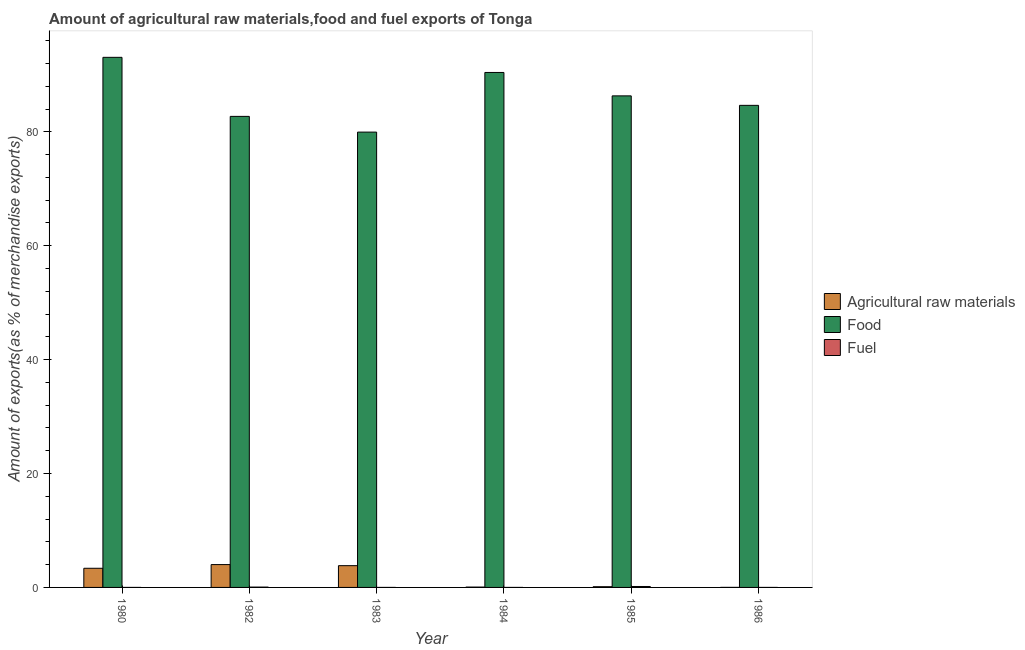How many different coloured bars are there?
Ensure brevity in your answer.  3. Are the number of bars per tick equal to the number of legend labels?
Ensure brevity in your answer.  Yes. How many bars are there on the 6th tick from the left?
Make the answer very short. 3. How many bars are there on the 4th tick from the right?
Your answer should be compact. 3. What is the label of the 5th group of bars from the left?
Offer a terse response. 1985. What is the percentage of raw materials exports in 1983?
Provide a succinct answer. 3.82. Across all years, what is the maximum percentage of food exports?
Your answer should be compact. 93.09. Across all years, what is the minimum percentage of raw materials exports?
Make the answer very short. 0.01. In which year was the percentage of raw materials exports maximum?
Offer a very short reply. 1982. What is the total percentage of raw materials exports in the graph?
Your answer should be compact. 11.39. What is the difference between the percentage of raw materials exports in 1980 and that in 1986?
Your answer should be compact. 3.36. What is the difference between the percentage of food exports in 1983 and the percentage of fuel exports in 1984?
Provide a short and direct response. -10.47. What is the average percentage of food exports per year?
Provide a short and direct response. 86.2. What is the ratio of the percentage of fuel exports in 1982 to that in 1984?
Keep it short and to the point. 92.06. What is the difference between the highest and the second highest percentage of raw materials exports?
Make the answer very short. 0.19. What is the difference between the highest and the lowest percentage of fuel exports?
Your response must be concise. 0.16. Is the sum of the percentage of food exports in 1980 and 1982 greater than the maximum percentage of fuel exports across all years?
Your answer should be very brief. Yes. What does the 1st bar from the left in 1980 represents?
Offer a very short reply. Agricultural raw materials. What does the 2nd bar from the right in 1980 represents?
Make the answer very short. Food. Is it the case that in every year, the sum of the percentage of raw materials exports and percentage of food exports is greater than the percentage of fuel exports?
Your answer should be very brief. Yes. How many bars are there?
Offer a very short reply. 18. How many years are there in the graph?
Make the answer very short. 6. Are the values on the major ticks of Y-axis written in scientific E-notation?
Keep it short and to the point. No. Does the graph contain grids?
Your response must be concise. No. What is the title of the graph?
Make the answer very short. Amount of agricultural raw materials,food and fuel exports of Tonga. What is the label or title of the Y-axis?
Ensure brevity in your answer.  Amount of exports(as % of merchandise exports). What is the Amount of exports(as % of merchandise exports) of Agricultural raw materials in 1980?
Your answer should be very brief. 3.36. What is the Amount of exports(as % of merchandise exports) in Food in 1980?
Keep it short and to the point. 93.09. What is the Amount of exports(as % of merchandise exports) of Fuel in 1980?
Offer a very short reply. 0. What is the Amount of exports(as % of merchandise exports) of Agricultural raw materials in 1982?
Keep it short and to the point. 4.01. What is the Amount of exports(as % of merchandise exports) in Food in 1982?
Ensure brevity in your answer.  82.72. What is the Amount of exports(as % of merchandise exports) in Fuel in 1982?
Give a very brief answer. 0.06. What is the Amount of exports(as % of merchandise exports) of Agricultural raw materials in 1983?
Your answer should be very brief. 3.82. What is the Amount of exports(as % of merchandise exports) in Food in 1983?
Provide a short and direct response. 79.96. What is the Amount of exports(as % of merchandise exports) of Fuel in 1983?
Offer a terse response. 0. What is the Amount of exports(as % of merchandise exports) of Agricultural raw materials in 1984?
Keep it short and to the point. 0.06. What is the Amount of exports(as % of merchandise exports) in Food in 1984?
Make the answer very short. 90.43. What is the Amount of exports(as % of merchandise exports) in Fuel in 1984?
Provide a succinct answer. 0. What is the Amount of exports(as % of merchandise exports) in Agricultural raw materials in 1985?
Your response must be concise. 0.13. What is the Amount of exports(as % of merchandise exports) in Food in 1985?
Offer a very short reply. 86.32. What is the Amount of exports(as % of merchandise exports) of Fuel in 1985?
Provide a succinct answer. 0.16. What is the Amount of exports(as % of merchandise exports) in Agricultural raw materials in 1986?
Provide a succinct answer. 0.01. What is the Amount of exports(as % of merchandise exports) in Food in 1986?
Your answer should be compact. 84.65. What is the Amount of exports(as % of merchandise exports) in Fuel in 1986?
Keep it short and to the point. 0. Across all years, what is the maximum Amount of exports(as % of merchandise exports) in Agricultural raw materials?
Provide a short and direct response. 4.01. Across all years, what is the maximum Amount of exports(as % of merchandise exports) of Food?
Provide a short and direct response. 93.09. Across all years, what is the maximum Amount of exports(as % of merchandise exports) of Fuel?
Ensure brevity in your answer.  0.16. Across all years, what is the minimum Amount of exports(as % of merchandise exports) of Agricultural raw materials?
Provide a succinct answer. 0.01. Across all years, what is the minimum Amount of exports(as % of merchandise exports) in Food?
Offer a very short reply. 79.96. Across all years, what is the minimum Amount of exports(as % of merchandise exports) in Fuel?
Your response must be concise. 0. What is the total Amount of exports(as % of merchandise exports) in Agricultural raw materials in the graph?
Offer a terse response. 11.39. What is the total Amount of exports(as % of merchandise exports) of Food in the graph?
Your response must be concise. 517.17. What is the total Amount of exports(as % of merchandise exports) of Fuel in the graph?
Ensure brevity in your answer.  0.22. What is the difference between the Amount of exports(as % of merchandise exports) in Agricultural raw materials in 1980 and that in 1982?
Your answer should be compact. -0.65. What is the difference between the Amount of exports(as % of merchandise exports) of Food in 1980 and that in 1982?
Ensure brevity in your answer.  10.37. What is the difference between the Amount of exports(as % of merchandise exports) in Fuel in 1980 and that in 1982?
Provide a succinct answer. -0.06. What is the difference between the Amount of exports(as % of merchandise exports) in Agricultural raw materials in 1980 and that in 1983?
Give a very brief answer. -0.46. What is the difference between the Amount of exports(as % of merchandise exports) of Food in 1980 and that in 1983?
Offer a terse response. 13.13. What is the difference between the Amount of exports(as % of merchandise exports) of Fuel in 1980 and that in 1983?
Your response must be concise. -0. What is the difference between the Amount of exports(as % of merchandise exports) of Agricultural raw materials in 1980 and that in 1984?
Your answer should be very brief. 3.3. What is the difference between the Amount of exports(as % of merchandise exports) in Food in 1980 and that in 1984?
Ensure brevity in your answer.  2.66. What is the difference between the Amount of exports(as % of merchandise exports) of Fuel in 1980 and that in 1984?
Offer a terse response. -0. What is the difference between the Amount of exports(as % of merchandise exports) in Agricultural raw materials in 1980 and that in 1985?
Provide a short and direct response. 3.24. What is the difference between the Amount of exports(as % of merchandise exports) in Food in 1980 and that in 1985?
Keep it short and to the point. 6.77. What is the difference between the Amount of exports(as % of merchandise exports) of Fuel in 1980 and that in 1985?
Keep it short and to the point. -0.16. What is the difference between the Amount of exports(as % of merchandise exports) of Agricultural raw materials in 1980 and that in 1986?
Your response must be concise. 3.36. What is the difference between the Amount of exports(as % of merchandise exports) in Food in 1980 and that in 1986?
Offer a terse response. 8.43. What is the difference between the Amount of exports(as % of merchandise exports) of Agricultural raw materials in 1982 and that in 1983?
Keep it short and to the point. 0.19. What is the difference between the Amount of exports(as % of merchandise exports) of Food in 1982 and that in 1983?
Offer a very short reply. 2.76. What is the difference between the Amount of exports(as % of merchandise exports) in Fuel in 1982 and that in 1983?
Your answer should be very brief. 0.06. What is the difference between the Amount of exports(as % of merchandise exports) in Agricultural raw materials in 1982 and that in 1984?
Your answer should be compact. 3.95. What is the difference between the Amount of exports(as % of merchandise exports) of Food in 1982 and that in 1984?
Your answer should be very brief. -7.71. What is the difference between the Amount of exports(as % of merchandise exports) in Fuel in 1982 and that in 1984?
Provide a short and direct response. 0.06. What is the difference between the Amount of exports(as % of merchandise exports) of Agricultural raw materials in 1982 and that in 1985?
Ensure brevity in your answer.  3.89. What is the difference between the Amount of exports(as % of merchandise exports) of Food in 1982 and that in 1985?
Offer a terse response. -3.6. What is the difference between the Amount of exports(as % of merchandise exports) in Fuel in 1982 and that in 1985?
Your response must be concise. -0.11. What is the difference between the Amount of exports(as % of merchandise exports) in Agricultural raw materials in 1982 and that in 1986?
Offer a terse response. 4. What is the difference between the Amount of exports(as % of merchandise exports) of Food in 1982 and that in 1986?
Provide a short and direct response. -1.94. What is the difference between the Amount of exports(as % of merchandise exports) in Fuel in 1982 and that in 1986?
Offer a terse response. 0.06. What is the difference between the Amount of exports(as % of merchandise exports) in Agricultural raw materials in 1983 and that in 1984?
Keep it short and to the point. 3.76. What is the difference between the Amount of exports(as % of merchandise exports) in Food in 1983 and that in 1984?
Provide a succinct answer. -10.47. What is the difference between the Amount of exports(as % of merchandise exports) in Fuel in 1983 and that in 1984?
Keep it short and to the point. -0. What is the difference between the Amount of exports(as % of merchandise exports) of Agricultural raw materials in 1983 and that in 1985?
Your answer should be very brief. 3.7. What is the difference between the Amount of exports(as % of merchandise exports) in Food in 1983 and that in 1985?
Your answer should be compact. -6.36. What is the difference between the Amount of exports(as % of merchandise exports) of Fuel in 1983 and that in 1985?
Ensure brevity in your answer.  -0.16. What is the difference between the Amount of exports(as % of merchandise exports) of Agricultural raw materials in 1983 and that in 1986?
Offer a terse response. 3.81. What is the difference between the Amount of exports(as % of merchandise exports) of Food in 1983 and that in 1986?
Give a very brief answer. -4.7. What is the difference between the Amount of exports(as % of merchandise exports) of Fuel in 1983 and that in 1986?
Your answer should be very brief. 0. What is the difference between the Amount of exports(as % of merchandise exports) in Agricultural raw materials in 1984 and that in 1985?
Offer a very short reply. -0.07. What is the difference between the Amount of exports(as % of merchandise exports) of Food in 1984 and that in 1985?
Your response must be concise. 4.11. What is the difference between the Amount of exports(as % of merchandise exports) in Fuel in 1984 and that in 1985?
Your response must be concise. -0.16. What is the difference between the Amount of exports(as % of merchandise exports) of Agricultural raw materials in 1984 and that in 1986?
Make the answer very short. 0.05. What is the difference between the Amount of exports(as % of merchandise exports) of Food in 1984 and that in 1986?
Your response must be concise. 5.78. What is the difference between the Amount of exports(as % of merchandise exports) in Agricultural raw materials in 1985 and that in 1986?
Offer a terse response. 0.12. What is the difference between the Amount of exports(as % of merchandise exports) in Food in 1985 and that in 1986?
Your answer should be very brief. 1.67. What is the difference between the Amount of exports(as % of merchandise exports) of Fuel in 1985 and that in 1986?
Make the answer very short. 0.16. What is the difference between the Amount of exports(as % of merchandise exports) of Agricultural raw materials in 1980 and the Amount of exports(as % of merchandise exports) of Food in 1982?
Your answer should be compact. -79.35. What is the difference between the Amount of exports(as % of merchandise exports) of Agricultural raw materials in 1980 and the Amount of exports(as % of merchandise exports) of Fuel in 1982?
Keep it short and to the point. 3.31. What is the difference between the Amount of exports(as % of merchandise exports) in Food in 1980 and the Amount of exports(as % of merchandise exports) in Fuel in 1982?
Offer a terse response. 93.03. What is the difference between the Amount of exports(as % of merchandise exports) of Agricultural raw materials in 1980 and the Amount of exports(as % of merchandise exports) of Food in 1983?
Ensure brevity in your answer.  -76.59. What is the difference between the Amount of exports(as % of merchandise exports) in Agricultural raw materials in 1980 and the Amount of exports(as % of merchandise exports) in Fuel in 1983?
Your answer should be very brief. 3.36. What is the difference between the Amount of exports(as % of merchandise exports) in Food in 1980 and the Amount of exports(as % of merchandise exports) in Fuel in 1983?
Keep it short and to the point. 93.09. What is the difference between the Amount of exports(as % of merchandise exports) of Agricultural raw materials in 1980 and the Amount of exports(as % of merchandise exports) of Food in 1984?
Give a very brief answer. -87.07. What is the difference between the Amount of exports(as % of merchandise exports) of Agricultural raw materials in 1980 and the Amount of exports(as % of merchandise exports) of Fuel in 1984?
Your answer should be very brief. 3.36. What is the difference between the Amount of exports(as % of merchandise exports) of Food in 1980 and the Amount of exports(as % of merchandise exports) of Fuel in 1984?
Provide a short and direct response. 93.09. What is the difference between the Amount of exports(as % of merchandise exports) of Agricultural raw materials in 1980 and the Amount of exports(as % of merchandise exports) of Food in 1985?
Make the answer very short. -82.96. What is the difference between the Amount of exports(as % of merchandise exports) in Agricultural raw materials in 1980 and the Amount of exports(as % of merchandise exports) in Fuel in 1985?
Your answer should be very brief. 3.2. What is the difference between the Amount of exports(as % of merchandise exports) of Food in 1980 and the Amount of exports(as % of merchandise exports) of Fuel in 1985?
Offer a very short reply. 92.92. What is the difference between the Amount of exports(as % of merchandise exports) of Agricultural raw materials in 1980 and the Amount of exports(as % of merchandise exports) of Food in 1986?
Provide a short and direct response. -81.29. What is the difference between the Amount of exports(as % of merchandise exports) of Agricultural raw materials in 1980 and the Amount of exports(as % of merchandise exports) of Fuel in 1986?
Your answer should be compact. 3.36. What is the difference between the Amount of exports(as % of merchandise exports) of Food in 1980 and the Amount of exports(as % of merchandise exports) of Fuel in 1986?
Keep it short and to the point. 93.09. What is the difference between the Amount of exports(as % of merchandise exports) of Agricultural raw materials in 1982 and the Amount of exports(as % of merchandise exports) of Food in 1983?
Your response must be concise. -75.95. What is the difference between the Amount of exports(as % of merchandise exports) in Agricultural raw materials in 1982 and the Amount of exports(as % of merchandise exports) in Fuel in 1983?
Give a very brief answer. 4.01. What is the difference between the Amount of exports(as % of merchandise exports) of Food in 1982 and the Amount of exports(as % of merchandise exports) of Fuel in 1983?
Offer a terse response. 82.72. What is the difference between the Amount of exports(as % of merchandise exports) in Agricultural raw materials in 1982 and the Amount of exports(as % of merchandise exports) in Food in 1984?
Keep it short and to the point. -86.42. What is the difference between the Amount of exports(as % of merchandise exports) of Agricultural raw materials in 1982 and the Amount of exports(as % of merchandise exports) of Fuel in 1984?
Your answer should be compact. 4.01. What is the difference between the Amount of exports(as % of merchandise exports) of Food in 1982 and the Amount of exports(as % of merchandise exports) of Fuel in 1984?
Keep it short and to the point. 82.72. What is the difference between the Amount of exports(as % of merchandise exports) of Agricultural raw materials in 1982 and the Amount of exports(as % of merchandise exports) of Food in 1985?
Provide a succinct answer. -82.31. What is the difference between the Amount of exports(as % of merchandise exports) of Agricultural raw materials in 1982 and the Amount of exports(as % of merchandise exports) of Fuel in 1985?
Your answer should be compact. 3.85. What is the difference between the Amount of exports(as % of merchandise exports) of Food in 1982 and the Amount of exports(as % of merchandise exports) of Fuel in 1985?
Give a very brief answer. 82.55. What is the difference between the Amount of exports(as % of merchandise exports) of Agricultural raw materials in 1982 and the Amount of exports(as % of merchandise exports) of Food in 1986?
Offer a very short reply. -80.64. What is the difference between the Amount of exports(as % of merchandise exports) in Agricultural raw materials in 1982 and the Amount of exports(as % of merchandise exports) in Fuel in 1986?
Provide a short and direct response. 4.01. What is the difference between the Amount of exports(as % of merchandise exports) of Food in 1982 and the Amount of exports(as % of merchandise exports) of Fuel in 1986?
Ensure brevity in your answer.  82.72. What is the difference between the Amount of exports(as % of merchandise exports) of Agricultural raw materials in 1983 and the Amount of exports(as % of merchandise exports) of Food in 1984?
Keep it short and to the point. -86.61. What is the difference between the Amount of exports(as % of merchandise exports) of Agricultural raw materials in 1983 and the Amount of exports(as % of merchandise exports) of Fuel in 1984?
Your response must be concise. 3.82. What is the difference between the Amount of exports(as % of merchandise exports) of Food in 1983 and the Amount of exports(as % of merchandise exports) of Fuel in 1984?
Ensure brevity in your answer.  79.96. What is the difference between the Amount of exports(as % of merchandise exports) in Agricultural raw materials in 1983 and the Amount of exports(as % of merchandise exports) in Food in 1985?
Provide a short and direct response. -82.5. What is the difference between the Amount of exports(as % of merchandise exports) in Agricultural raw materials in 1983 and the Amount of exports(as % of merchandise exports) in Fuel in 1985?
Provide a succinct answer. 3.66. What is the difference between the Amount of exports(as % of merchandise exports) in Food in 1983 and the Amount of exports(as % of merchandise exports) in Fuel in 1985?
Offer a very short reply. 79.79. What is the difference between the Amount of exports(as % of merchandise exports) in Agricultural raw materials in 1983 and the Amount of exports(as % of merchandise exports) in Food in 1986?
Provide a short and direct response. -80.83. What is the difference between the Amount of exports(as % of merchandise exports) of Agricultural raw materials in 1983 and the Amount of exports(as % of merchandise exports) of Fuel in 1986?
Your answer should be compact. 3.82. What is the difference between the Amount of exports(as % of merchandise exports) in Food in 1983 and the Amount of exports(as % of merchandise exports) in Fuel in 1986?
Make the answer very short. 79.96. What is the difference between the Amount of exports(as % of merchandise exports) in Agricultural raw materials in 1984 and the Amount of exports(as % of merchandise exports) in Food in 1985?
Provide a succinct answer. -86.26. What is the difference between the Amount of exports(as % of merchandise exports) of Agricultural raw materials in 1984 and the Amount of exports(as % of merchandise exports) of Fuel in 1985?
Provide a succinct answer. -0.1. What is the difference between the Amount of exports(as % of merchandise exports) of Food in 1984 and the Amount of exports(as % of merchandise exports) of Fuel in 1985?
Your answer should be very brief. 90.27. What is the difference between the Amount of exports(as % of merchandise exports) of Agricultural raw materials in 1984 and the Amount of exports(as % of merchandise exports) of Food in 1986?
Your answer should be very brief. -84.6. What is the difference between the Amount of exports(as % of merchandise exports) in Agricultural raw materials in 1984 and the Amount of exports(as % of merchandise exports) in Fuel in 1986?
Offer a very short reply. 0.06. What is the difference between the Amount of exports(as % of merchandise exports) of Food in 1984 and the Amount of exports(as % of merchandise exports) of Fuel in 1986?
Provide a short and direct response. 90.43. What is the difference between the Amount of exports(as % of merchandise exports) in Agricultural raw materials in 1985 and the Amount of exports(as % of merchandise exports) in Food in 1986?
Your response must be concise. -84.53. What is the difference between the Amount of exports(as % of merchandise exports) in Agricultural raw materials in 1985 and the Amount of exports(as % of merchandise exports) in Fuel in 1986?
Ensure brevity in your answer.  0.13. What is the difference between the Amount of exports(as % of merchandise exports) of Food in 1985 and the Amount of exports(as % of merchandise exports) of Fuel in 1986?
Give a very brief answer. 86.32. What is the average Amount of exports(as % of merchandise exports) of Agricultural raw materials per year?
Ensure brevity in your answer.  1.9. What is the average Amount of exports(as % of merchandise exports) in Food per year?
Provide a short and direct response. 86.19. What is the average Amount of exports(as % of merchandise exports) in Fuel per year?
Give a very brief answer. 0.04. In the year 1980, what is the difference between the Amount of exports(as % of merchandise exports) in Agricultural raw materials and Amount of exports(as % of merchandise exports) in Food?
Keep it short and to the point. -89.72. In the year 1980, what is the difference between the Amount of exports(as % of merchandise exports) in Agricultural raw materials and Amount of exports(as % of merchandise exports) in Fuel?
Provide a succinct answer. 3.36. In the year 1980, what is the difference between the Amount of exports(as % of merchandise exports) of Food and Amount of exports(as % of merchandise exports) of Fuel?
Provide a short and direct response. 93.09. In the year 1982, what is the difference between the Amount of exports(as % of merchandise exports) of Agricultural raw materials and Amount of exports(as % of merchandise exports) of Food?
Keep it short and to the point. -78.71. In the year 1982, what is the difference between the Amount of exports(as % of merchandise exports) in Agricultural raw materials and Amount of exports(as % of merchandise exports) in Fuel?
Make the answer very short. 3.95. In the year 1982, what is the difference between the Amount of exports(as % of merchandise exports) of Food and Amount of exports(as % of merchandise exports) of Fuel?
Offer a terse response. 82.66. In the year 1983, what is the difference between the Amount of exports(as % of merchandise exports) in Agricultural raw materials and Amount of exports(as % of merchandise exports) in Food?
Make the answer very short. -76.14. In the year 1983, what is the difference between the Amount of exports(as % of merchandise exports) of Agricultural raw materials and Amount of exports(as % of merchandise exports) of Fuel?
Your response must be concise. 3.82. In the year 1983, what is the difference between the Amount of exports(as % of merchandise exports) of Food and Amount of exports(as % of merchandise exports) of Fuel?
Your answer should be compact. 79.96. In the year 1984, what is the difference between the Amount of exports(as % of merchandise exports) of Agricultural raw materials and Amount of exports(as % of merchandise exports) of Food?
Give a very brief answer. -90.37. In the year 1984, what is the difference between the Amount of exports(as % of merchandise exports) in Agricultural raw materials and Amount of exports(as % of merchandise exports) in Fuel?
Offer a very short reply. 0.06. In the year 1984, what is the difference between the Amount of exports(as % of merchandise exports) in Food and Amount of exports(as % of merchandise exports) in Fuel?
Ensure brevity in your answer.  90.43. In the year 1985, what is the difference between the Amount of exports(as % of merchandise exports) of Agricultural raw materials and Amount of exports(as % of merchandise exports) of Food?
Offer a very short reply. -86.2. In the year 1985, what is the difference between the Amount of exports(as % of merchandise exports) of Agricultural raw materials and Amount of exports(as % of merchandise exports) of Fuel?
Your answer should be compact. -0.04. In the year 1985, what is the difference between the Amount of exports(as % of merchandise exports) of Food and Amount of exports(as % of merchandise exports) of Fuel?
Make the answer very short. 86.16. In the year 1986, what is the difference between the Amount of exports(as % of merchandise exports) in Agricultural raw materials and Amount of exports(as % of merchandise exports) in Food?
Make the answer very short. -84.65. In the year 1986, what is the difference between the Amount of exports(as % of merchandise exports) of Agricultural raw materials and Amount of exports(as % of merchandise exports) of Fuel?
Make the answer very short. 0.01. In the year 1986, what is the difference between the Amount of exports(as % of merchandise exports) in Food and Amount of exports(as % of merchandise exports) in Fuel?
Offer a very short reply. 84.65. What is the ratio of the Amount of exports(as % of merchandise exports) in Agricultural raw materials in 1980 to that in 1982?
Offer a very short reply. 0.84. What is the ratio of the Amount of exports(as % of merchandise exports) of Food in 1980 to that in 1982?
Give a very brief answer. 1.13. What is the ratio of the Amount of exports(as % of merchandise exports) of Fuel in 1980 to that in 1982?
Offer a very short reply. 0. What is the ratio of the Amount of exports(as % of merchandise exports) in Agricultural raw materials in 1980 to that in 1983?
Your response must be concise. 0.88. What is the ratio of the Amount of exports(as % of merchandise exports) of Food in 1980 to that in 1983?
Make the answer very short. 1.16. What is the ratio of the Amount of exports(as % of merchandise exports) in Fuel in 1980 to that in 1983?
Offer a very short reply. 0.48. What is the ratio of the Amount of exports(as % of merchandise exports) of Agricultural raw materials in 1980 to that in 1984?
Make the answer very short. 56.45. What is the ratio of the Amount of exports(as % of merchandise exports) of Food in 1980 to that in 1984?
Your response must be concise. 1.03. What is the ratio of the Amount of exports(as % of merchandise exports) in Fuel in 1980 to that in 1984?
Provide a short and direct response. 0.24. What is the ratio of the Amount of exports(as % of merchandise exports) of Agricultural raw materials in 1980 to that in 1985?
Provide a short and direct response. 26.84. What is the ratio of the Amount of exports(as % of merchandise exports) in Food in 1980 to that in 1985?
Make the answer very short. 1.08. What is the ratio of the Amount of exports(as % of merchandise exports) in Fuel in 1980 to that in 1985?
Offer a terse response. 0. What is the ratio of the Amount of exports(as % of merchandise exports) in Agricultural raw materials in 1980 to that in 1986?
Your response must be concise. 396.72. What is the ratio of the Amount of exports(as % of merchandise exports) in Food in 1980 to that in 1986?
Make the answer very short. 1.1. What is the ratio of the Amount of exports(as % of merchandise exports) of Fuel in 1980 to that in 1986?
Provide a succinct answer. 1.08. What is the ratio of the Amount of exports(as % of merchandise exports) in Agricultural raw materials in 1982 to that in 1983?
Provide a succinct answer. 1.05. What is the ratio of the Amount of exports(as % of merchandise exports) in Food in 1982 to that in 1983?
Your response must be concise. 1.03. What is the ratio of the Amount of exports(as % of merchandise exports) of Fuel in 1982 to that in 1983?
Your answer should be compact. 183.45. What is the ratio of the Amount of exports(as % of merchandise exports) of Agricultural raw materials in 1982 to that in 1984?
Provide a succinct answer. 67.31. What is the ratio of the Amount of exports(as % of merchandise exports) of Food in 1982 to that in 1984?
Offer a very short reply. 0.91. What is the ratio of the Amount of exports(as % of merchandise exports) in Fuel in 1982 to that in 1984?
Ensure brevity in your answer.  92.06. What is the ratio of the Amount of exports(as % of merchandise exports) of Agricultural raw materials in 1982 to that in 1985?
Your response must be concise. 32.01. What is the ratio of the Amount of exports(as % of merchandise exports) of Fuel in 1982 to that in 1985?
Your answer should be compact. 0.35. What is the ratio of the Amount of exports(as % of merchandise exports) in Agricultural raw materials in 1982 to that in 1986?
Provide a succinct answer. 473.09. What is the ratio of the Amount of exports(as % of merchandise exports) of Food in 1982 to that in 1986?
Keep it short and to the point. 0.98. What is the ratio of the Amount of exports(as % of merchandise exports) in Fuel in 1982 to that in 1986?
Ensure brevity in your answer.  410.56. What is the ratio of the Amount of exports(as % of merchandise exports) of Agricultural raw materials in 1983 to that in 1984?
Offer a terse response. 64.1. What is the ratio of the Amount of exports(as % of merchandise exports) of Food in 1983 to that in 1984?
Offer a very short reply. 0.88. What is the ratio of the Amount of exports(as % of merchandise exports) of Fuel in 1983 to that in 1984?
Provide a short and direct response. 0.5. What is the ratio of the Amount of exports(as % of merchandise exports) in Agricultural raw materials in 1983 to that in 1985?
Your answer should be very brief. 30.48. What is the ratio of the Amount of exports(as % of merchandise exports) in Food in 1983 to that in 1985?
Your answer should be compact. 0.93. What is the ratio of the Amount of exports(as % of merchandise exports) of Fuel in 1983 to that in 1985?
Offer a terse response. 0. What is the ratio of the Amount of exports(as % of merchandise exports) of Agricultural raw materials in 1983 to that in 1986?
Provide a succinct answer. 450.52. What is the ratio of the Amount of exports(as % of merchandise exports) in Food in 1983 to that in 1986?
Provide a succinct answer. 0.94. What is the ratio of the Amount of exports(as % of merchandise exports) in Fuel in 1983 to that in 1986?
Give a very brief answer. 2.24. What is the ratio of the Amount of exports(as % of merchandise exports) of Agricultural raw materials in 1984 to that in 1985?
Keep it short and to the point. 0.48. What is the ratio of the Amount of exports(as % of merchandise exports) of Food in 1984 to that in 1985?
Make the answer very short. 1.05. What is the ratio of the Amount of exports(as % of merchandise exports) in Fuel in 1984 to that in 1985?
Provide a short and direct response. 0. What is the ratio of the Amount of exports(as % of merchandise exports) of Agricultural raw materials in 1984 to that in 1986?
Make the answer very short. 7.03. What is the ratio of the Amount of exports(as % of merchandise exports) of Food in 1984 to that in 1986?
Provide a succinct answer. 1.07. What is the ratio of the Amount of exports(as % of merchandise exports) of Fuel in 1984 to that in 1986?
Offer a very short reply. 4.46. What is the ratio of the Amount of exports(as % of merchandise exports) in Agricultural raw materials in 1985 to that in 1986?
Keep it short and to the point. 14.78. What is the ratio of the Amount of exports(as % of merchandise exports) in Food in 1985 to that in 1986?
Your answer should be very brief. 1.02. What is the ratio of the Amount of exports(as % of merchandise exports) in Fuel in 1985 to that in 1986?
Provide a short and direct response. 1167.45. What is the difference between the highest and the second highest Amount of exports(as % of merchandise exports) in Agricultural raw materials?
Offer a very short reply. 0.19. What is the difference between the highest and the second highest Amount of exports(as % of merchandise exports) in Food?
Your answer should be very brief. 2.66. What is the difference between the highest and the second highest Amount of exports(as % of merchandise exports) in Fuel?
Your response must be concise. 0.11. What is the difference between the highest and the lowest Amount of exports(as % of merchandise exports) in Agricultural raw materials?
Offer a very short reply. 4. What is the difference between the highest and the lowest Amount of exports(as % of merchandise exports) of Food?
Your response must be concise. 13.13. What is the difference between the highest and the lowest Amount of exports(as % of merchandise exports) of Fuel?
Provide a succinct answer. 0.16. 